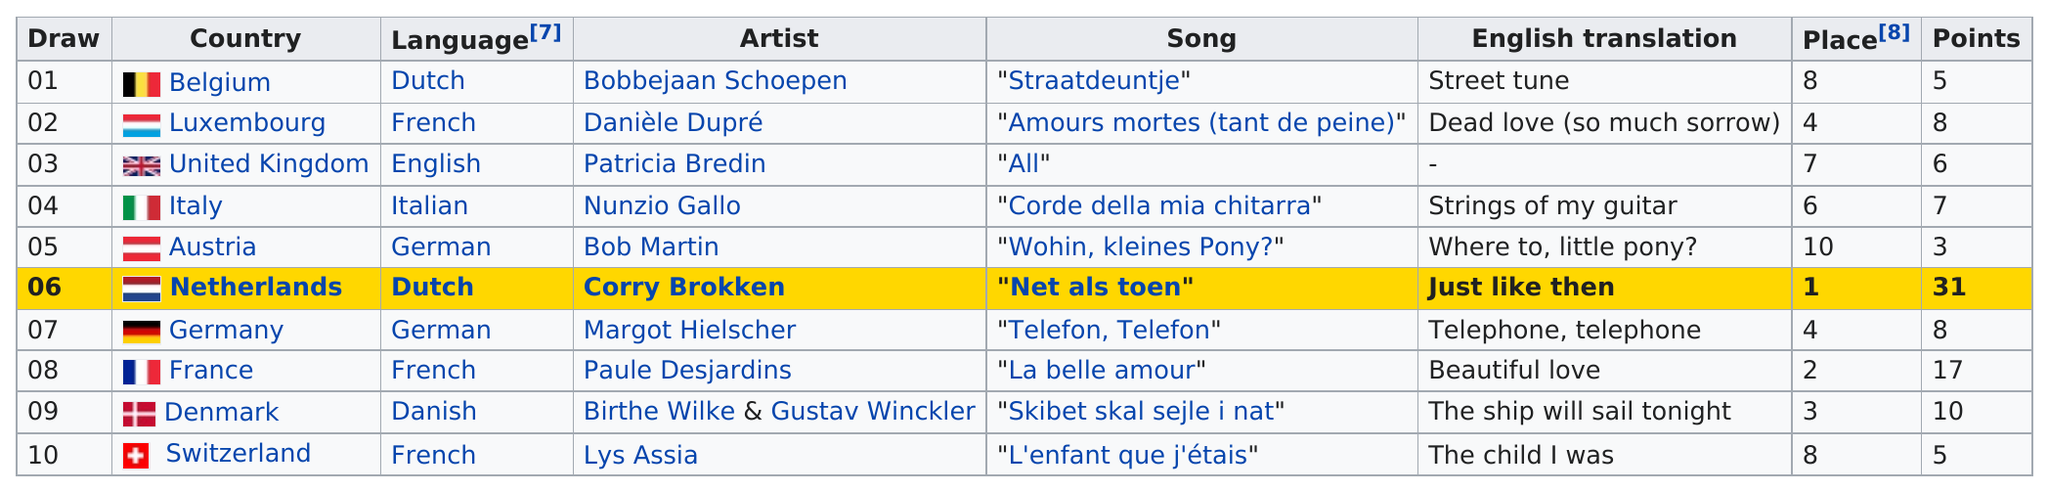List a handful of essential elements in this visual. Austria came in last place in the competition. The top song was from the Netherlands. The song 'L'enfant que j'étais' received the same number of points as 'straatdeuntje.' There are three French-speaking artists depicted in the drawing. The song "Net als toen" was the only one to receive more than 20 points. 